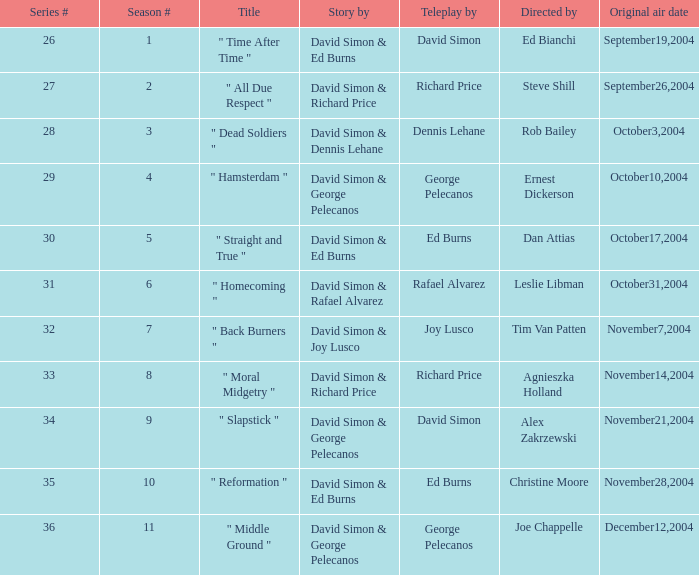Who wrote the teleplay when rob bailey is the director? Dennis Lehane. 